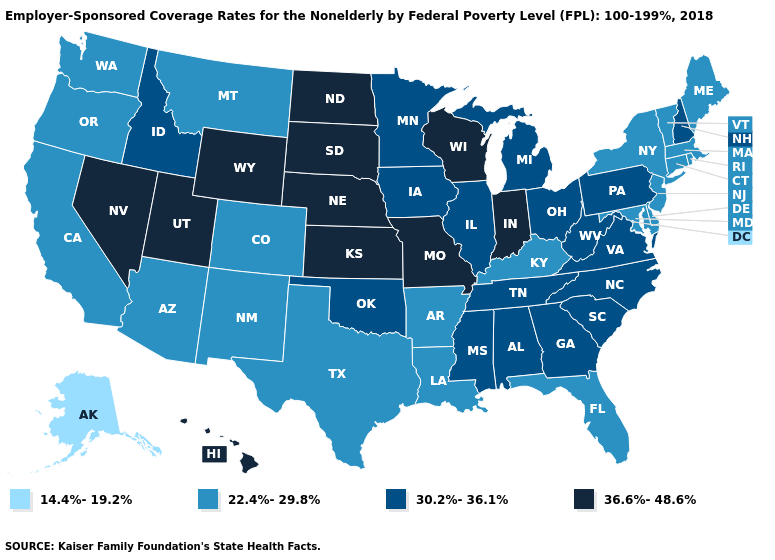Does Florida have a higher value than Montana?
Write a very short answer. No. What is the value of Maine?
Write a very short answer. 22.4%-29.8%. Among the states that border West Virginia , which have the highest value?
Be succinct. Ohio, Pennsylvania, Virginia. What is the value of Connecticut?
Quick response, please. 22.4%-29.8%. Among the states that border Wisconsin , which have the lowest value?
Be succinct. Illinois, Iowa, Michigan, Minnesota. What is the highest value in states that border Alabama?
Answer briefly. 30.2%-36.1%. What is the lowest value in states that border New Mexico?
Short answer required. 22.4%-29.8%. What is the value of Oklahoma?
Give a very brief answer. 30.2%-36.1%. What is the lowest value in the USA?
Answer briefly. 14.4%-19.2%. Name the states that have a value in the range 36.6%-48.6%?
Be succinct. Hawaii, Indiana, Kansas, Missouri, Nebraska, Nevada, North Dakota, South Dakota, Utah, Wisconsin, Wyoming. What is the lowest value in the Northeast?
Write a very short answer. 22.4%-29.8%. What is the value of South Carolina?
Write a very short answer. 30.2%-36.1%. Name the states that have a value in the range 22.4%-29.8%?
Give a very brief answer. Arizona, Arkansas, California, Colorado, Connecticut, Delaware, Florida, Kentucky, Louisiana, Maine, Maryland, Massachusetts, Montana, New Jersey, New Mexico, New York, Oregon, Rhode Island, Texas, Vermont, Washington. Does Nebraska have the highest value in the USA?
Short answer required. Yes. Does North Dakota have the highest value in the USA?
Answer briefly. Yes. 